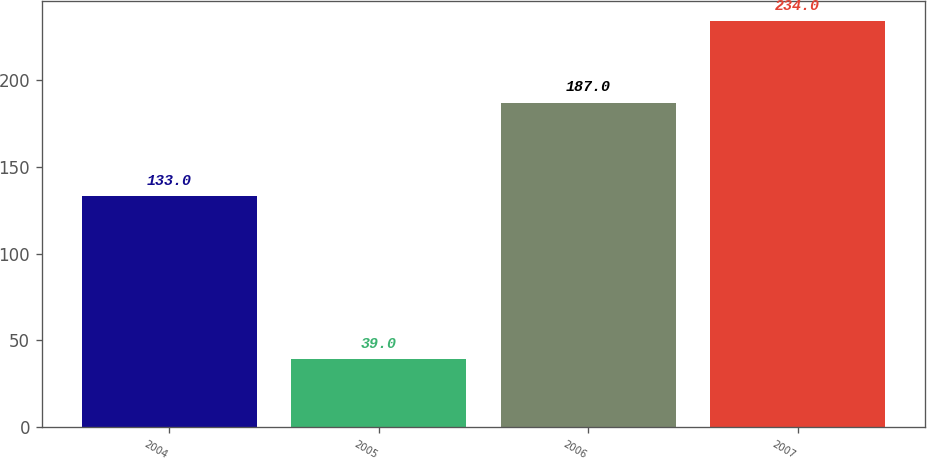Convert chart. <chart><loc_0><loc_0><loc_500><loc_500><bar_chart><fcel>2004<fcel>2005<fcel>2006<fcel>2007<nl><fcel>133<fcel>39<fcel>187<fcel>234<nl></chart> 